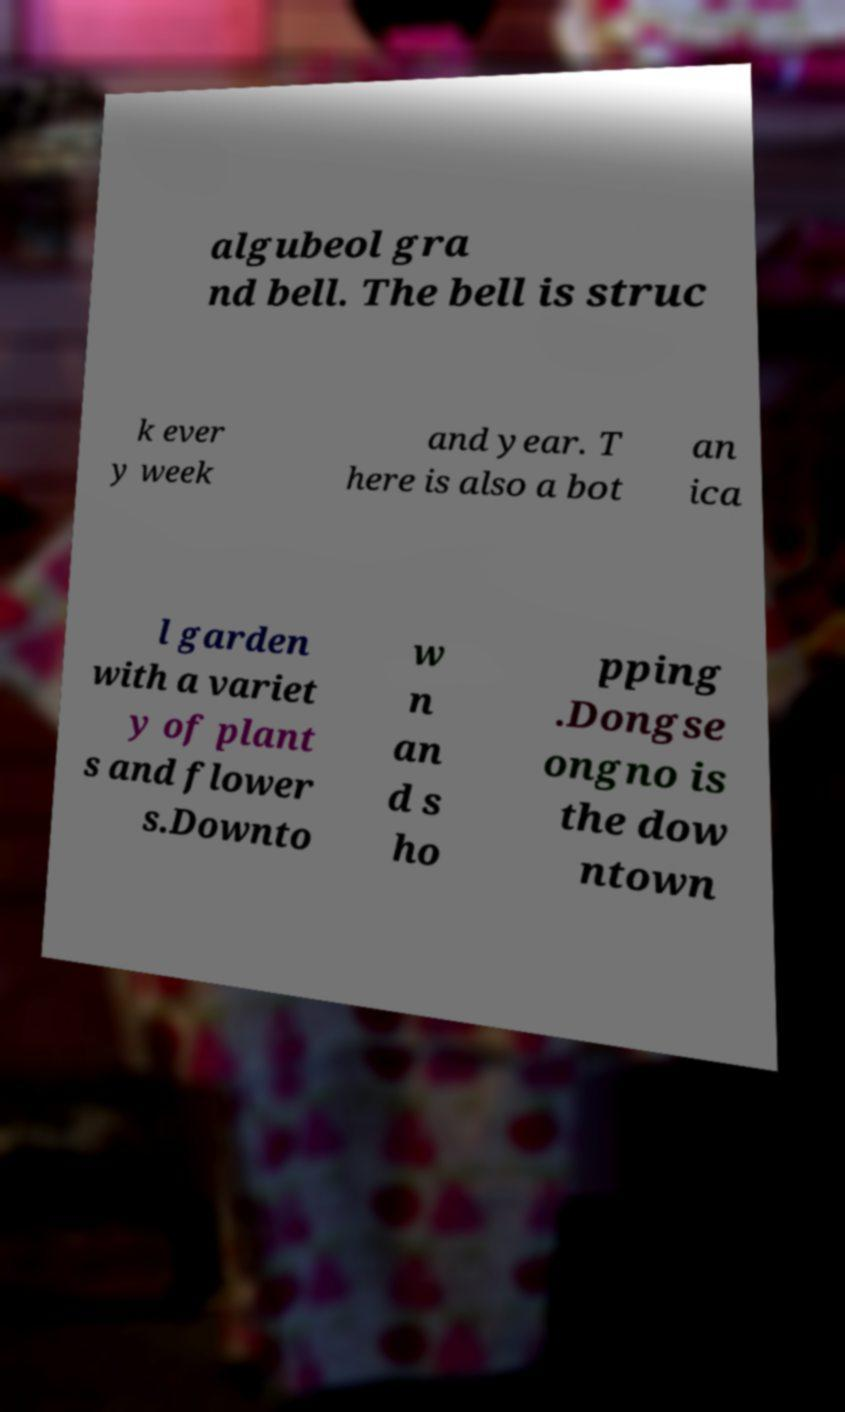Could you assist in decoding the text presented in this image and type it out clearly? algubeol gra nd bell. The bell is struc k ever y week and year. T here is also a bot an ica l garden with a variet y of plant s and flower s.Downto w n an d s ho pping .Dongse ongno is the dow ntown 